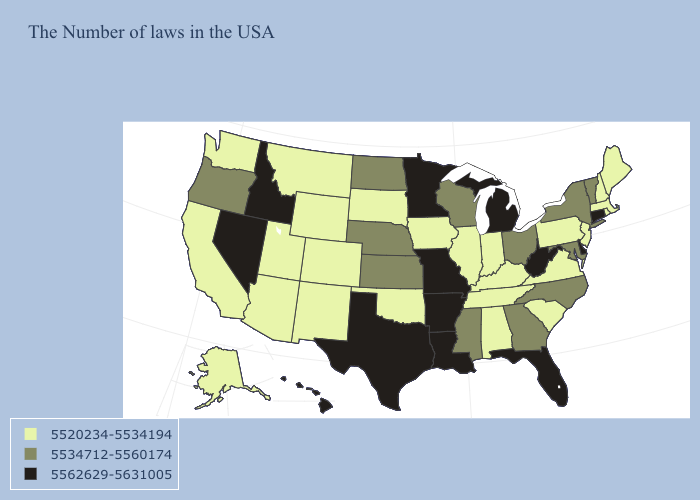Does the first symbol in the legend represent the smallest category?
Be succinct. Yes. Among the states that border Minnesota , does North Dakota have the highest value?
Give a very brief answer. Yes. Name the states that have a value in the range 5534712-5560174?
Quick response, please. Vermont, New York, Maryland, North Carolina, Ohio, Georgia, Wisconsin, Mississippi, Kansas, Nebraska, North Dakota, Oregon. Is the legend a continuous bar?
Give a very brief answer. No. Name the states that have a value in the range 5520234-5534194?
Write a very short answer. Maine, Massachusetts, Rhode Island, New Hampshire, New Jersey, Pennsylvania, Virginia, South Carolina, Kentucky, Indiana, Alabama, Tennessee, Illinois, Iowa, Oklahoma, South Dakota, Wyoming, Colorado, New Mexico, Utah, Montana, Arizona, California, Washington, Alaska. What is the lowest value in the Northeast?
Write a very short answer. 5520234-5534194. Name the states that have a value in the range 5534712-5560174?
Be succinct. Vermont, New York, Maryland, North Carolina, Ohio, Georgia, Wisconsin, Mississippi, Kansas, Nebraska, North Dakota, Oregon. Name the states that have a value in the range 5534712-5560174?
Answer briefly. Vermont, New York, Maryland, North Carolina, Ohio, Georgia, Wisconsin, Mississippi, Kansas, Nebraska, North Dakota, Oregon. What is the lowest value in the Northeast?
Be succinct. 5520234-5534194. Which states hav the highest value in the Northeast?
Be succinct. Connecticut. Does Oregon have the lowest value in the West?
Write a very short answer. No. Does Maine have a lower value than Missouri?
Keep it brief. Yes. What is the highest value in the South ?
Give a very brief answer. 5562629-5631005. Does the first symbol in the legend represent the smallest category?
Be succinct. Yes. What is the highest value in the Northeast ?
Concise answer only. 5562629-5631005. 